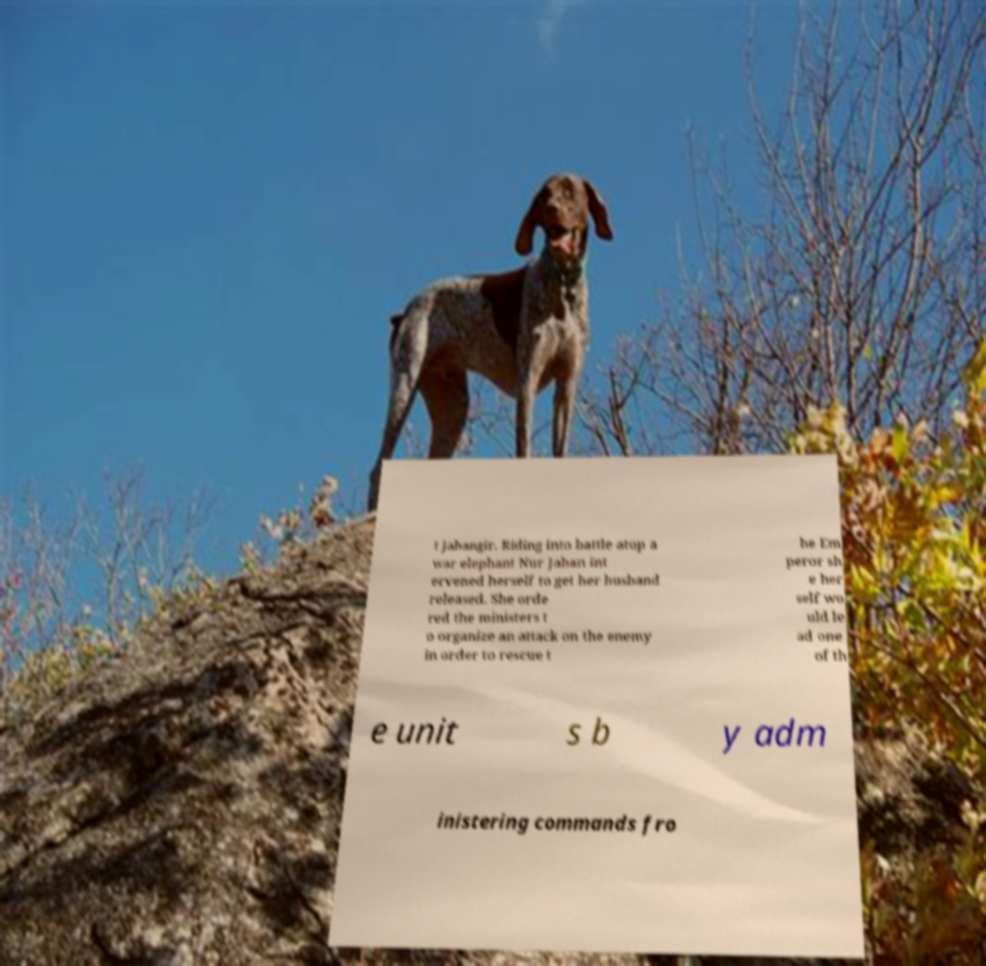Could you extract and type out the text from this image? t Jahangir. Riding into battle atop a war elephant Nur Jahan int ervened herself to get her husband released. She orde red the ministers t o organize an attack on the enemy in order to rescue t he Em peror sh e her self wo uld le ad one of th e unit s b y adm inistering commands fro 